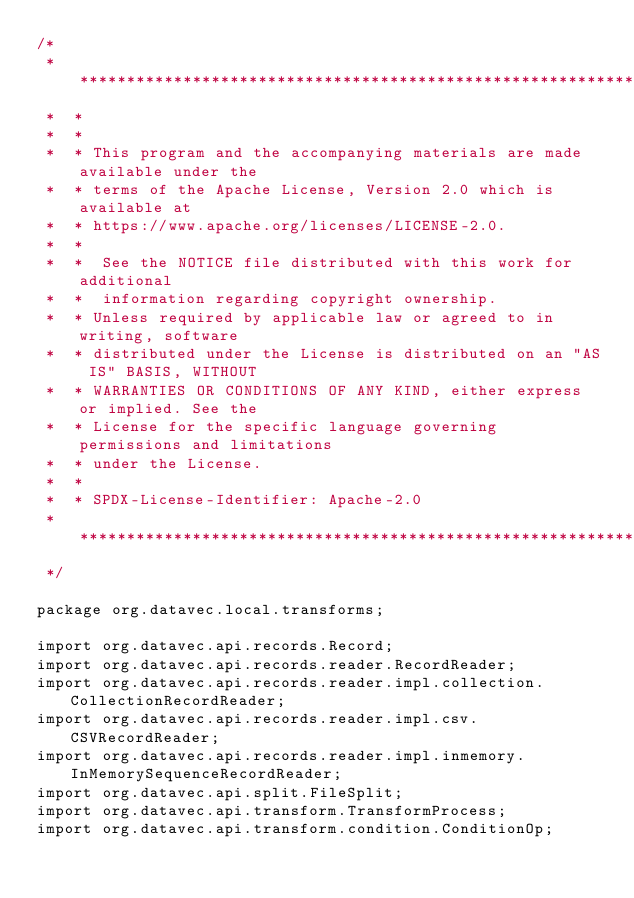Convert code to text. <code><loc_0><loc_0><loc_500><loc_500><_Java_>/*
 *  ******************************************************************************
 *  *
 *  *
 *  * This program and the accompanying materials are made available under the
 *  * terms of the Apache License, Version 2.0 which is available at
 *  * https://www.apache.org/licenses/LICENSE-2.0.
 *  *
 *  *  See the NOTICE file distributed with this work for additional
 *  *  information regarding copyright ownership.
 *  * Unless required by applicable law or agreed to in writing, software
 *  * distributed under the License is distributed on an "AS IS" BASIS, WITHOUT
 *  * WARRANTIES OR CONDITIONS OF ANY KIND, either express or implied. See the
 *  * License for the specific language governing permissions and limitations
 *  * under the License.
 *  *
 *  * SPDX-License-Identifier: Apache-2.0
 *  *****************************************************************************
 */

package org.datavec.local.transforms;

import org.datavec.api.records.Record;
import org.datavec.api.records.reader.RecordReader;
import org.datavec.api.records.reader.impl.collection.CollectionRecordReader;
import org.datavec.api.records.reader.impl.csv.CSVRecordReader;
import org.datavec.api.records.reader.impl.inmemory.InMemorySequenceRecordReader;
import org.datavec.api.split.FileSplit;
import org.datavec.api.transform.TransformProcess;
import org.datavec.api.transform.condition.ConditionOp;</code> 